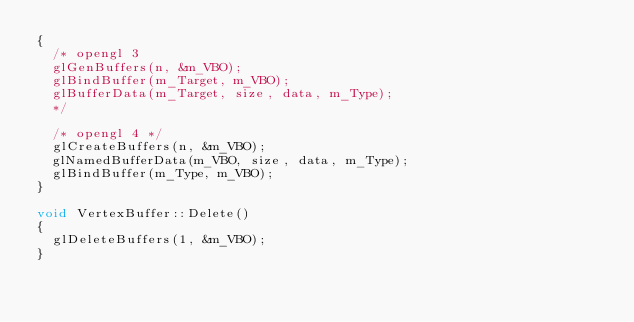Convert code to text. <code><loc_0><loc_0><loc_500><loc_500><_C++_>{
	/* opengl 3 
	glGenBuffers(n, &m_VBO);
	glBindBuffer(m_Target, m_VBO);
	glBufferData(m_Target, size, data, m_Type);
	*/

	/* opengl 4 */
	glCreateBuffers(n, &m_VBO);
	glNamedBufferData(m_VBO, size, data, m_Type);
	glBindBuffer(m_Type, m_VBO);
}

void VertexBuffer::Delete()
{
	glDeleteBuffers(1, &m_VBO);
}</code> 